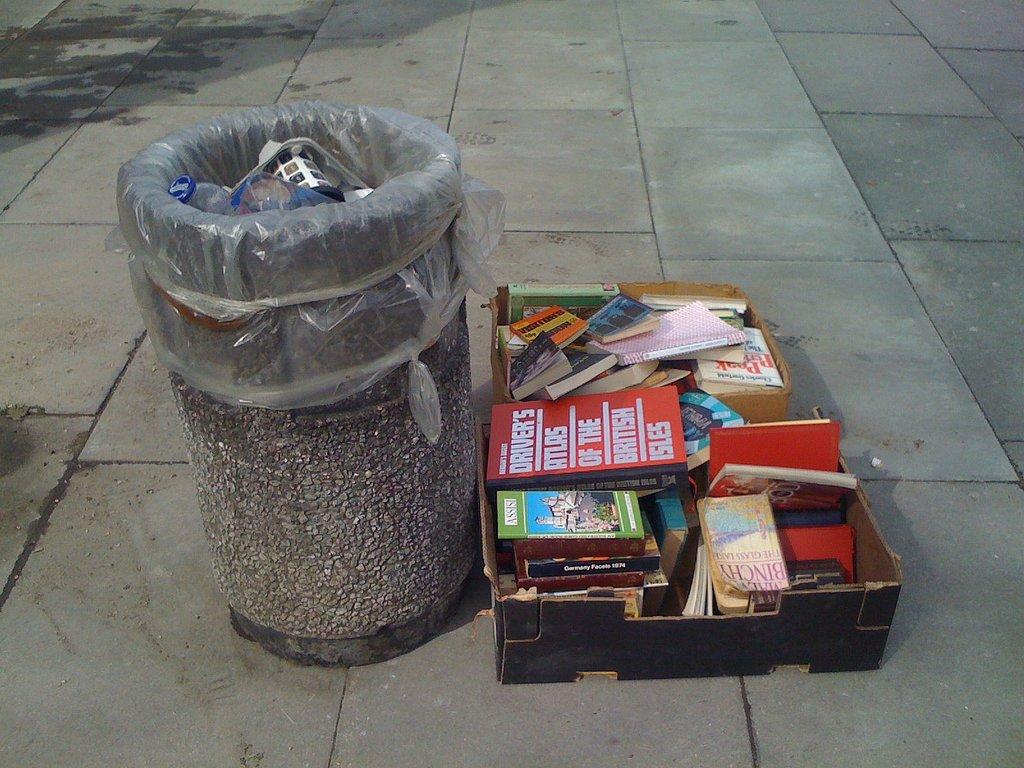What is the first word on the red book?
Your answer should be very brief. Driver's. 